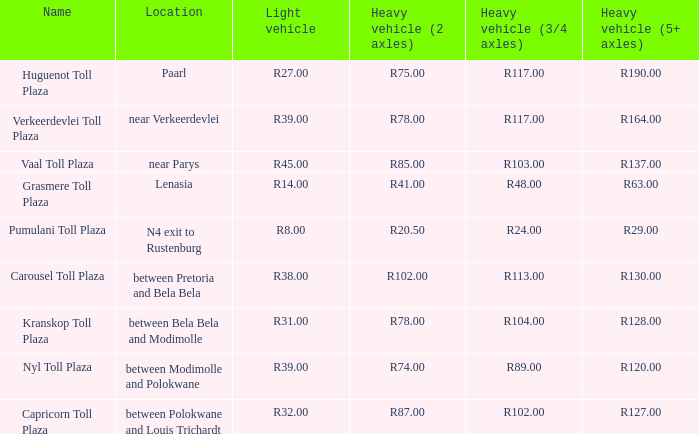50? Pumulani Toll Plaza. 